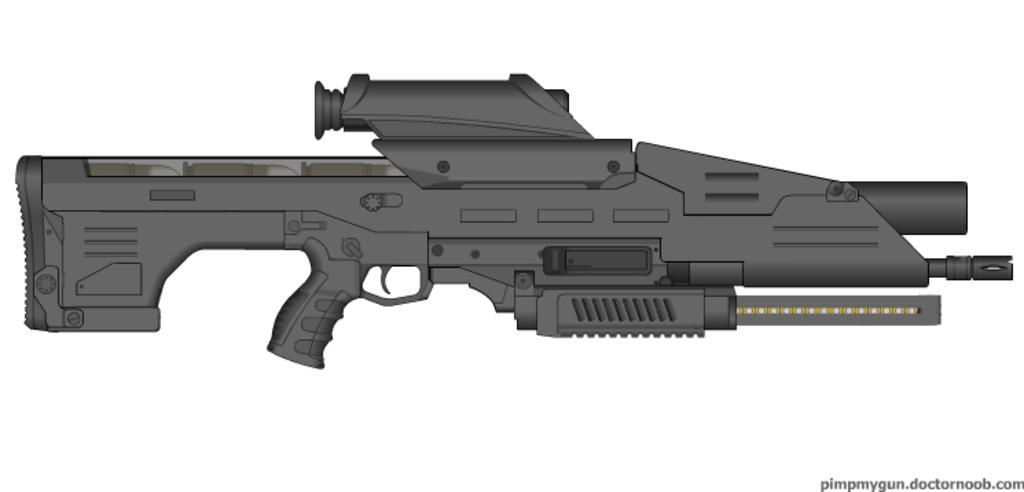What type of image is being described? The image is animated. What object can be seen in the image? There is a rifle in the image. Where is the watermark located in the image? The watermark is at the bottom right side of the image. What color is the background of the image? The background of the image is white. Can you see a bear playing in the river in the image? No, there is no bear or river present in the image. What type of tool is being used to rake leaves in the image? There is no rake or leaves present in the image. 